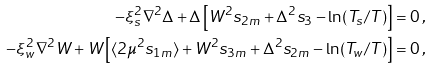<formula> <loc_0><loc_0><loc_500><loc_500>- \xi _ { s } ^ { 2 } \nabla ^ { 2 } \Delta + \Delta \left [ W ^ { 2 } s _ { 2 m } + \Delta ^ { 2 } s _ { 3 } - \ln ( T _ { s } / T ) \right ] & = 0 \, , \\ - \xi _ { w } ^ { 2 } \nabla ^ { 2 } W + W \left [ \langle 2 \mu ^ { 2 } s _ { 1 m } \rangle + W ^ { 2 } s _ { 3 m } + \Delta ^ { 2 } s _ { 2 m } - \ln ( T _ { w } / T ) \right ] & = 0 \, ,</formula> 